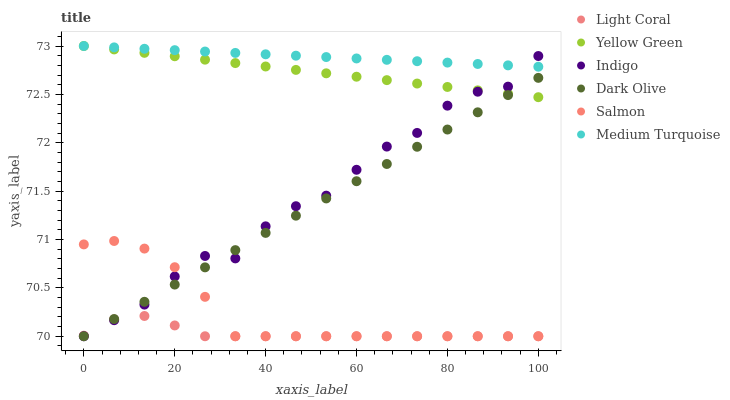Does Light Coral have the minimum area under the curve?
Answer yes or no. Yes. Does Medium Turquoise have the maximum area under the curve?
Answer yes or no. Yes. Does Yellow Green have the minimum area under the curve?
Answer yes or no. No. Does Yellow Green have the maximum area under the curve?
Answer yes or no. No. Is Yellow Green the smoothest?
Answer yes or no. Yes. Is Indigo the roughest?
Answer yes or no. Yes. Is Dark Olive the smoothest?
Answer yes or no. No. Is Dark Olive the roughest?
Answer yes or no. No. Does Indigo have the lowest value?
Answer yes or no. Yes. Does Yellow Green have the lowest value?
Answer yes or no. No. Does Medium Turquoise have the highest value?
Answer yes or no. Yes. Does Dark Olive have the highest value?
Answer yes or no. No. Is Dark Olive less than Medium Turquoise?
Answer yes or no. Yes. Is Medium Turquoise greater than Dark Olive?
Answer yes or no. Yes. Does Indigo intersect Salmon?
Answer yes or no. Yes. Is Indigo less than Salmon?
Answer yes or no. No. Is Indigo greater than Salmon?
Answer yes or no. No. Does Dark Olive intersect Medium Turquoise?
Answer yes or no. No. 